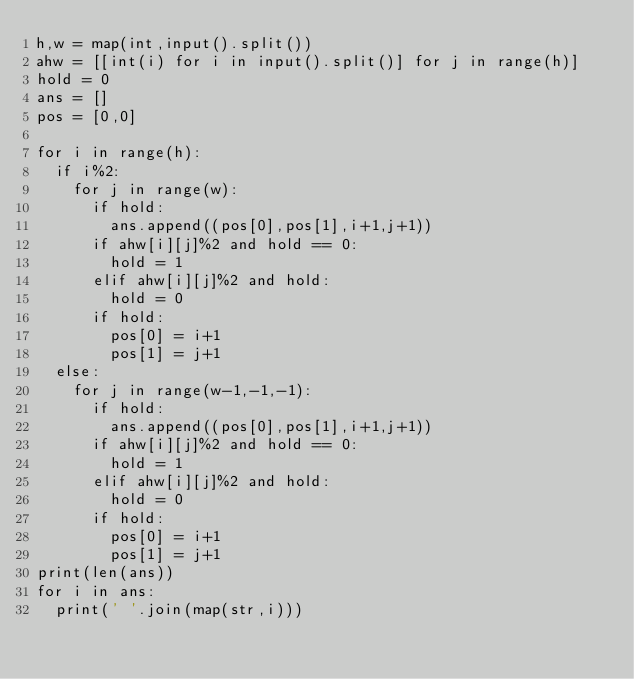Convert code to text. <code><loc_0><loc_0><loc_500><loc_500><_Python_>h,w = map(int,input().split())
ahw = [[int(i) for i in input().split()] for j in range(h)]
hold = 0
ans = []
pos = [0,0]

for i in range(h):
  if i%2:
    for j in range(w):
      if hold:
        ans.append((pos[0],pos[1],i+1,j+1))
      if ahw[i][j]%2 and hold == 0:
        hold = 1
      elif ahw[i][j]%2 and hold:
        hold = 0
      if hold:
        pos[0] = i+1
        pos[1] = j+1
  else:
    for j in range(w-1,-1,-1):
      if hold:
        ans.append((pos[0],pos[1],i+1,j+1))
      if ahw[i][j]%2 and hold == 0:
        hold = 1
      elif ahw[i][j]%2 and hold:
        hold = 0
      if hold:
        pos[0] = i+1
        pos[1] = j+1
print(len(ans))
for i in ans:
  print(' '.join(map(str,i)))</code> 